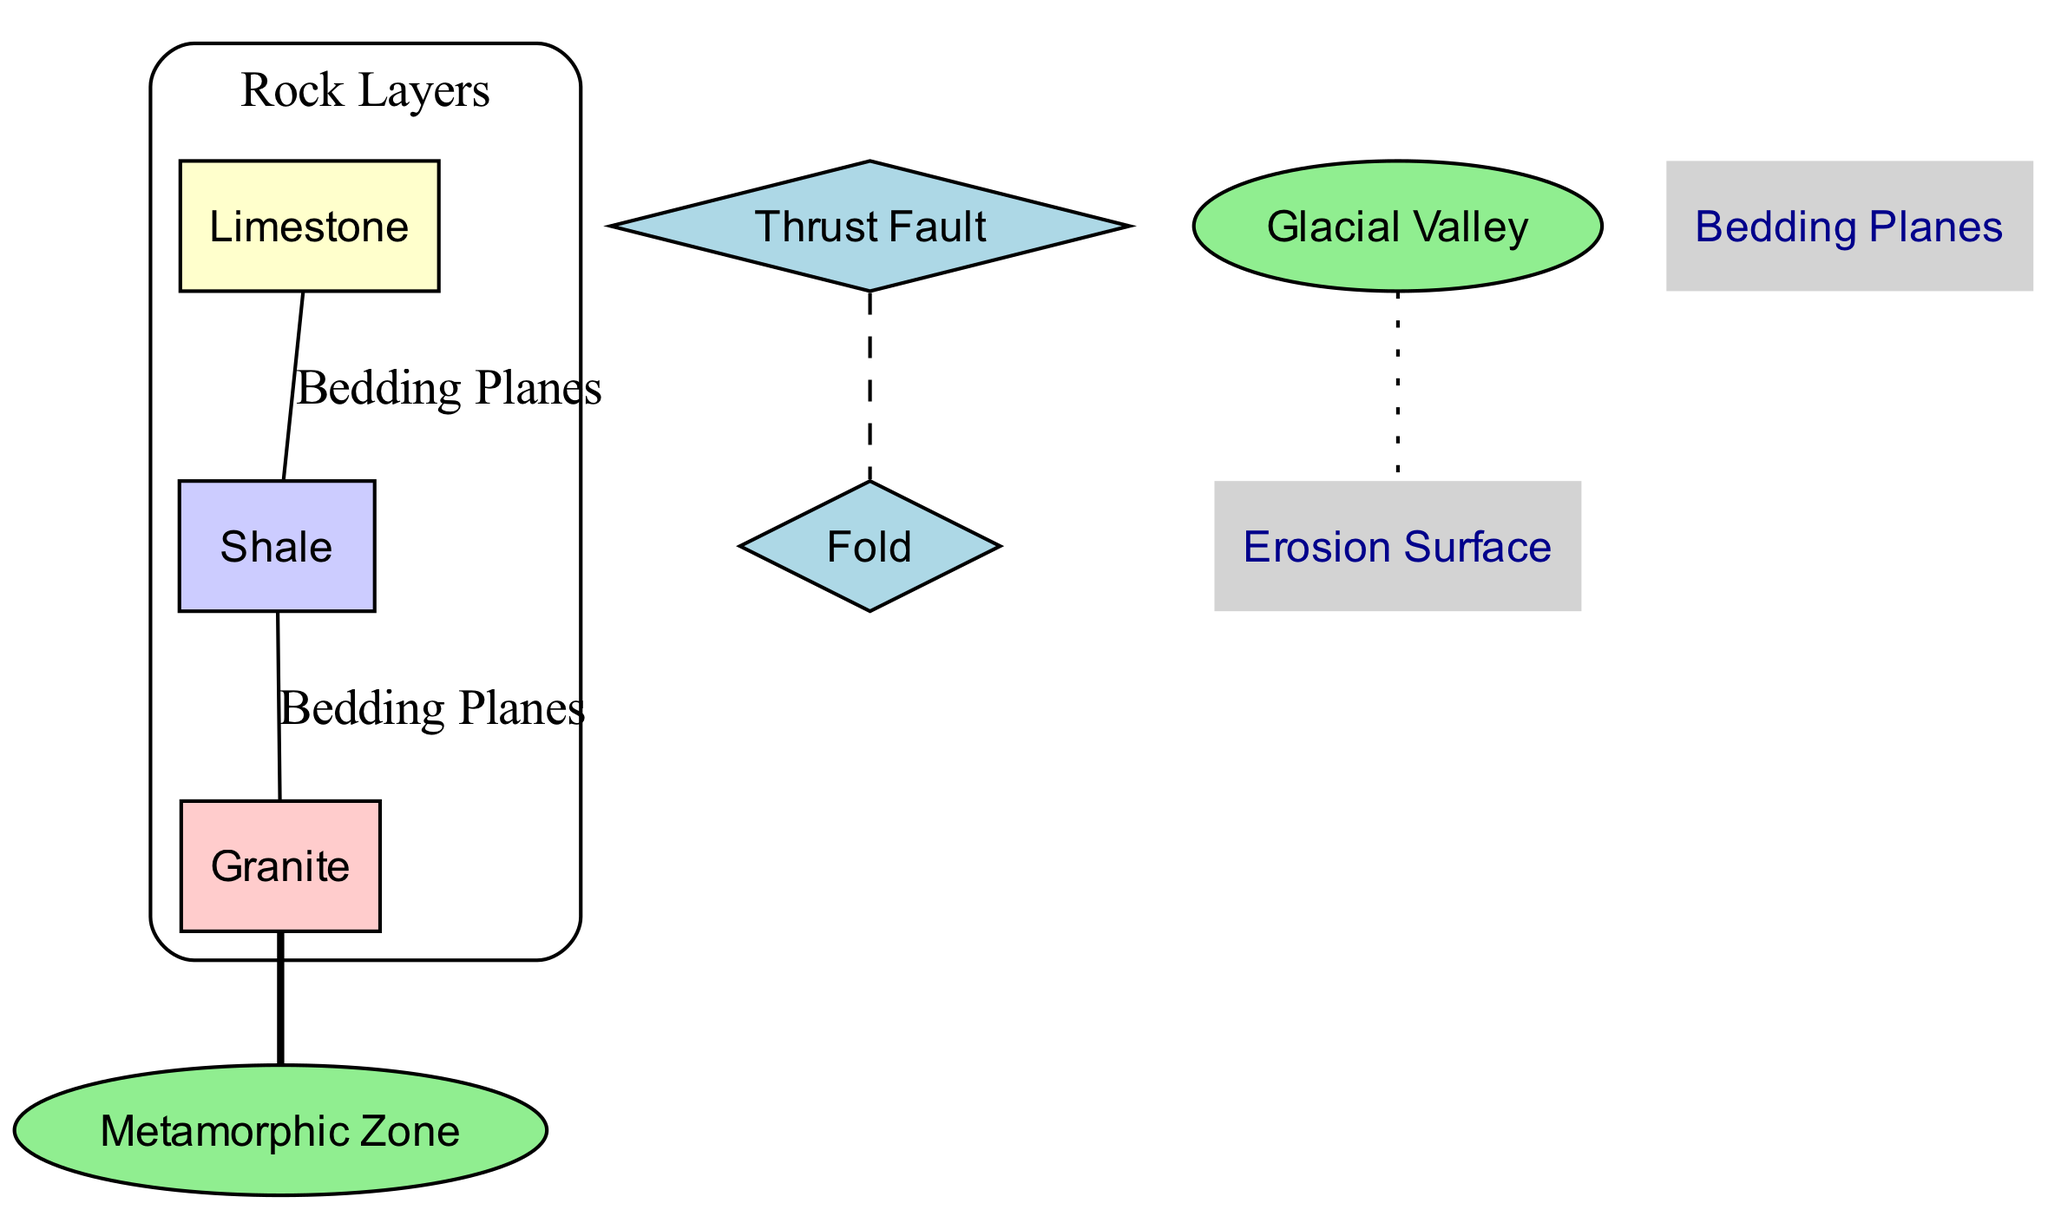What is the top layer in the cross-section? The diagram indicates that the top layer is labeled as "Limestone". This is a direct observation from the placement of the elements in the diagram.
Answer: Limestone How many rock layers are shown in the diagram? By counting the distinct layers listed in the diagram - Limestone, Shale, and Granite - there are three rock layers depicted.
Answer: 3 What geological feature is located at the surface? The diagram specifies that the "Glacial Valley" is positioned at the surface, making it a prominent feature in the cross-section.
Answer: Glacial Valley What geological formation indicates an older rock pushed over younger rock? The "Thrust Fault" is described in the diagram as the process where older rock is displaced over younger rock, based on the description associated with it.
Answer: Thrust Fault What layer is directly beneath Shale? Looking at the order of the layers, Shale is directly above Granite, as per the connections shown in the diagram.
Answer: Granite What do the Bedding Planes connect? The Bedding Planes connect the layers of Limestone and Shale and Shale and Granite, representing the transitions between these rock layers in the diagram.
Answer: Limestone and Shale, Shale and Granite Which zone is indicated to be at a deeper position in the cross-section? The "Metamorphic Zone" is denoted as being located deep within the layers according to the information provided in the diagram.
Answer: Metamorphic Zone What does the Fold formation indicate? The Fold formation is associated with bent layers resulting from tectonic pressure, as described in the diagram, indicating a process of geological stress.
Answer: Bent layers due to tectonic pressure What is the position of the Erosion Surface in the diagram? The Erosion Surface is detailed as being at the top of the cross-section, aligning with its role as a layer of erosion shown in the diagram.
Answer: Top 